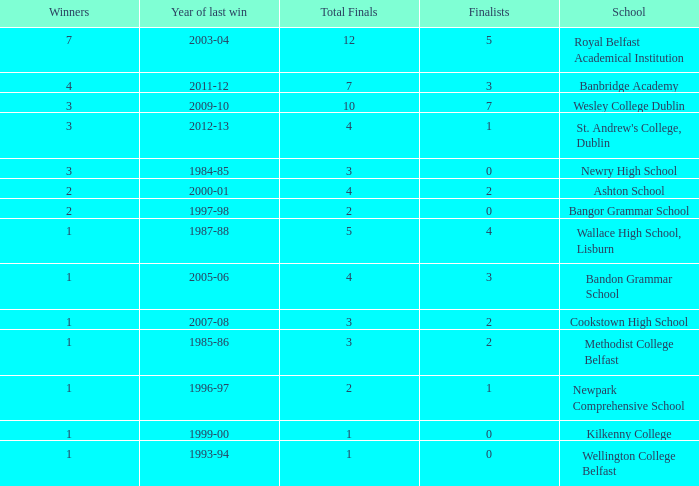How many times was banbridge academy the winner? 1.0. 